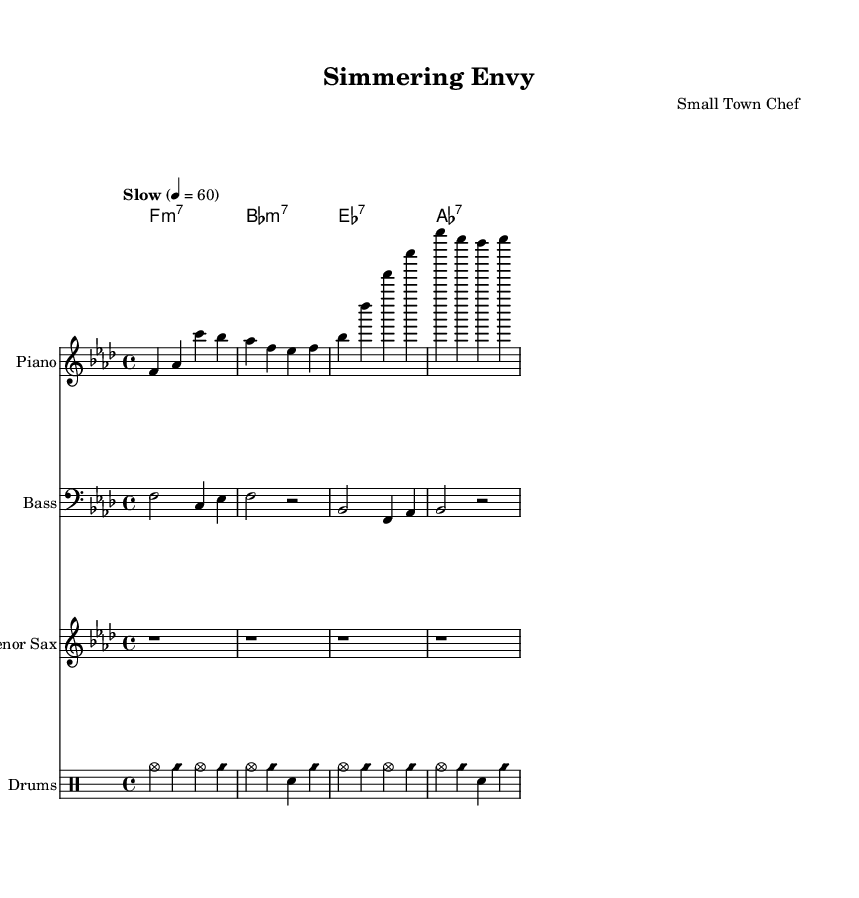What is the key signature of this music? The key signature is indicated by the key signature clef and the absence of sharps or flats in the written music staff. In this piece, there are four flats, which correspond to F minor.
Answer: F minor What is the time signature of this music? The time signature is shown at the beginning of the score. In this case, it is specified as 4/4, which means there are four beats in each measure and the quarter note receives one beat.
Answer: 4/4 What is the tempo marking for this piece? The tempo marking is indicated above the music and reads "Slow" with a metronome marking of 60 beats per minute, suggesting a leisurely pace.
Answer: Slow Which instrument plays the melody in this arrangement? The melody is primarily carried by the piano part, which prominently features the highest notes and the defined melodic line.
Answer: Piano How many measures are there in the piano part? By counting the distinct groupings of notes and bar lines in the piano staff specifically, it can be determined that there are a total of four measures in the piano part.
Answer: 4 What type of jazz form is primarily used in this piece? The typical structure for jazz ballads, especially those focusing on melancholic themes, often includes a AABA form. This can be inferred from the repeated melodic phrases and chord progressions throughout the piece.
Answer: AABA 